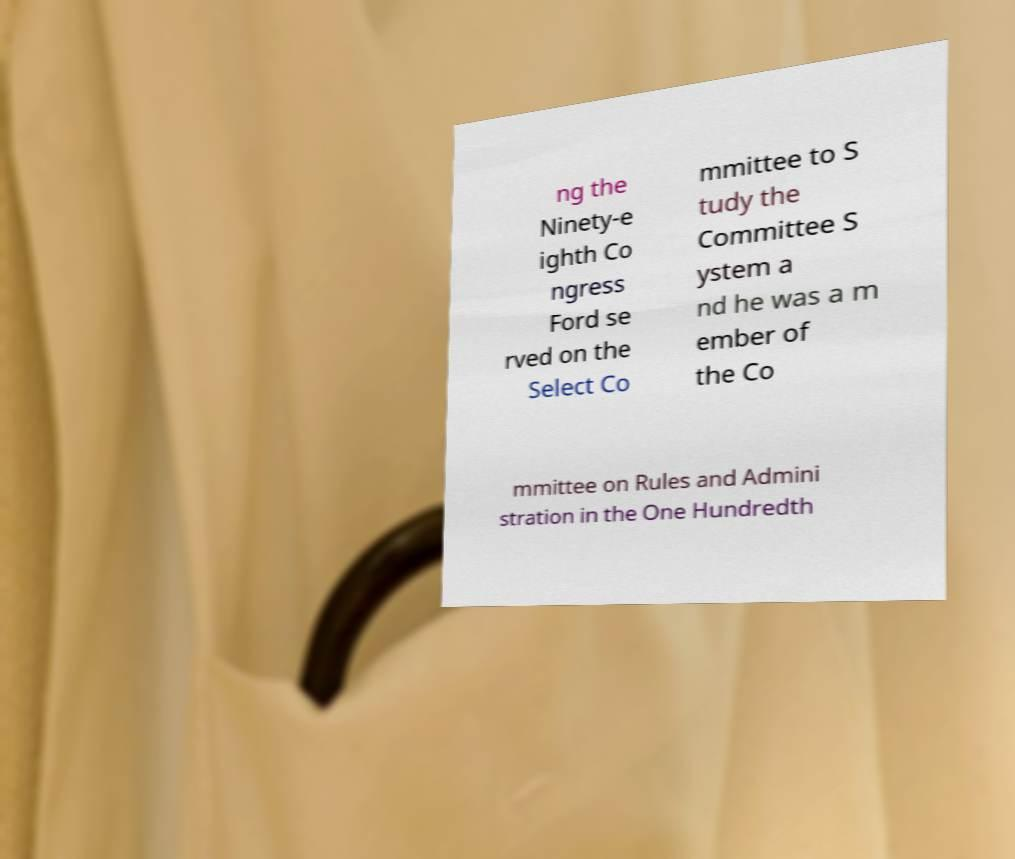I need the written content from this picture converted into text. Can you do that? ng the Ninety-e ighth Co ngress Ford se rved on the Select Co mmittee to S tudy the Committee S ystem a nd he was a m ember of the Co mmittee on Rules and Admini stration in the One Hundredth 